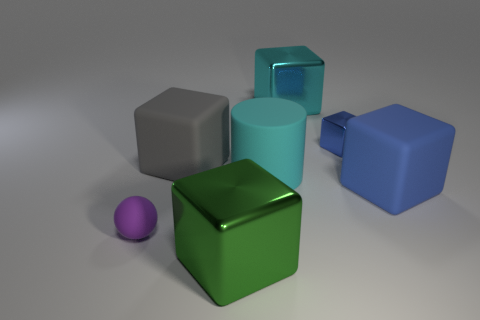Can you describe the lighting source direction based on the shadows presented? Certainly. The lighting in the image seems to be coming from the upper right side. This is deduced from the direction of the shadows cast to the lower left by each object, indicating a single consistent light source.  How does the lighting affect the perception of the object's dimensions? The lighting enhances the three-dimensionality of the objects by casting shadows and highlights that define their shape. The light source creates a contrast that helps in perceiving the depth and relative size of the objects. 